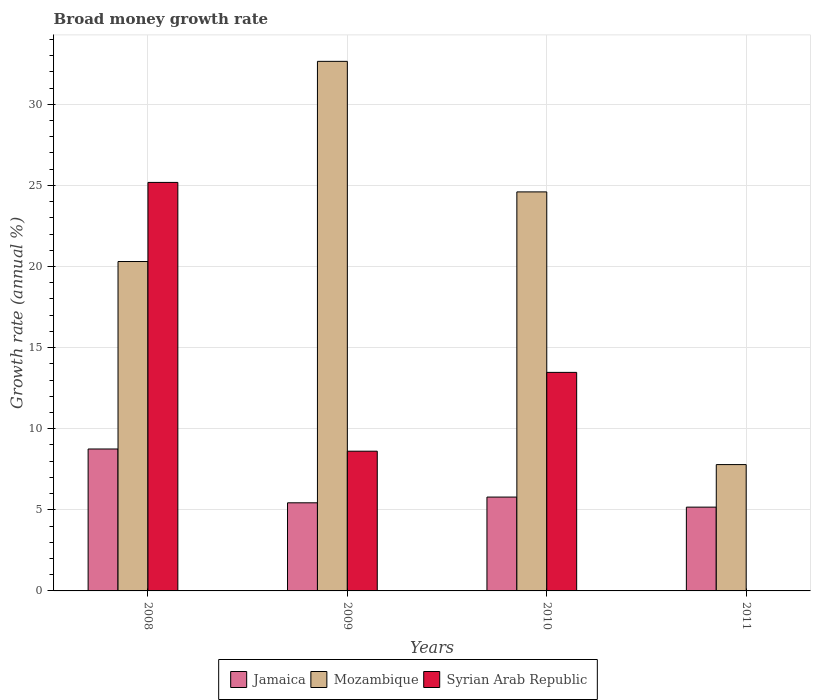How many different coloured bars are there?
Keep it short and to the point. 3. How many groups of bars are there?
Provide a short and direct response. 4. What is the label of the 4th group of bars from the left?
Give a very brief answer. 2011. What is the growth rate in Jamaica in 2010?
Make the answer very short. 5.79. Across all years, what is the maximum growth rate in Jamaica?
Give a very brief answer. 8.75. Across all years, what is the minimum growth rate in Mozambique?
Your answer should be compact. 7.79. What is the total growth rate in Jamaica in the graph?
Provide a short and direct response. 25.13. What is the difference between the growth rate in Jamaica in 2009 and that in 2011?
Provide a short and direct response. 0.27. What is the difference between the growth rate in Syrian Arab Republic in 2011 and the growth rate in Mozambique in 2009?
Give a very brief answer. -32.64. What is the average growth rate in Mozambique per year?
Offer a very short reply. 21.33. In the year 2010, what is the difference between the growth rate in Syrian Arab Republic and growth rate in Jamaica?
Ensure brevity in your answer.  7.69. What is the ratio of the growth rate in Mozambique in 2009 to that in 2011?
Keep it short and to the point. 4.19. Is the growth rate in Jamaica in 2008 less than that in 2011?
Give a very brief answer. No. Is the difference between the growth rate in Syrian Arab Republic in 2008 and 2009 greater than the difference between the growth rate in Jamaica in 2008 and 2009?
Provide a succinct answer. Yes. What is the difference between the highest and the second highest growth rate in Syrian Arab Republic?
Offer a terse response. 11.71. What is the difference between the highest and the lowest growth rate in Syrian Arab Republic?
Provide a short and direct response. 25.18. Is it the case that in every year, the sum of the growth rate in Syrian Arab Republic and growth rate in Mozambique is greater than the growth rate in Jamaica?
Your answer should be very brief. Yes. How many bars are there?
Offer a terse response. 11. How many years are there in the graph?
Make the answer very short. 4. What is the difference between two consecutive major ticks on the Y-axis?
Offer a very short reply. 5. How are the legend labels stacked?
Make the answer very short. Horizontal. What is the title of the graph?
Provide a succinct answer. Broad money growth rate. What is the label or title of the X-axis?
Your answer should be compact. Years. What is the label or title of the Y-axis?
Keep it short and to the point. Growth rate (annual %). What is the Growth rate (annual %) of Jamaica in 2008?
Make the answer very short. 8.75. What is the Growth rate (annual %) in Mozambique in 2008?
Your answer should be compact. 20.3. What is the Growth rate (annual %) in Syrian Arab Republic in 2008?
Ensure brevity in your answer.  25.18. What is the Growth rate (annual %) in Jamaica in 2009?
Keep it short and to the point. 5.43. What is the Growth rate (annual %) in Mozambique in 2009?
Provide a short and direct response. 32.64. What is the Growth rate (annual %) of Syrian Arab Republic in 2009?
Provide a succinct answer. 8.61. What is the Growth rate (annual %) in Jamaica in 2010?
Offer a very short reply. 5.79. What is the Growth rate (annual %) in Mozambique in 2010?
Offer a terse response. 24.6. What is the Growth rate (annual %) of Syrian Arab Republic in 2010?
Your answer should be very brief. 13.47. What is the Growth rate (annual %) in Jamaica in 2011?
Your response must be concise. 5.16. What is the Growth rate (annual %) of Mozambique in 2011?
Make the answer very short. 7.79. What is the Growth rate (annual %) in Syrian Arab Republic in 2011?
Offer a very short reply. 0. Across all years, what is the maximum Growth rate (annual %) in Jamaica?
Provide a succinct answer. 8.75. Across all years, what is the maximum Growth rate (annual %) of Mozambique?
Your answer should be very brief. 32.64. Across all years, what is the maximum Growth rate (annual %) of Syrian Arab Republic?
Your answer should be compact. 25.18. Across all years, what is the minimum Growth rate (annual %) of Jamaica?
Ensure brevity in your answer.  5.16. Across all years, what is the minimum Growth rate (annual %) in Mozambique?
Give a very brief answer. 7.79. What is the total Growth rate (annual %) of Jamaica in the graph?
Provide a short and direct response. 25.13. What is the total Growth rate (annual %) of Mozambique in the graph?
Offer a terse response. 85.33. What is the total Growth rate (annual %) of Syrian Arab Republic in the graph?
Provide a succinct answer. 47.27. What is the difference between the Growth rate (annual %) of Jamaica in 2008 and that in 2009?
Make the answer very short. 3.32. What is the difference between the Growth rate (annual %) of Mozambique in 2008 and that in 2009?
Provide a short and direct response. -12.34. What is the difference between the Growth rate (annual %) of Syrian Arab Republic in 2008 and that in 2009?
Provide a succinct answer. 16.57. What is the difference between the Growth rate (annual %) of Jamaica in 2008 and that in 2010?
Keep it short and to the point. 2.96. What is the difference between the Growth rate (annual %) in Mozambique in 2008 and that in 2010?
Offer a terse response. -4.29. What is the difference between the Growth rate (annual %) in Syrian Arab Republic in 2008 and that in 2010?
Offer a terse response. 11.71. What is the difference between the Growth rate (annual %) of Jamaica in 2008 and that in 2011?
Provide a succinct answer. 3.58. What is the difference between the Growth rate (annual %) in Mozambique in 2008 and that in 2011?
Offer a very short reply. 12.52. What is the difference between the Growth rate (annual %) of Jamaica in 2009 and that in 2010?
Offer a terse response. -0.35. What is the difference between the Growth rate (annual %) of Mozambique in 2009 and that in 2010?
Ensure brevity in your answer.  8.05. What is the difference between the Growth rate (annual %) of Syrian Arab Republic in 2009 and that in 2010?
Provide a short and direct response. -4.86. What is the difference between the Growth rate (annual %) of Jamaica in 2009 and that in 2011?
Make the answer very short. 0.27. What is the difference between the Growth rate (annual %) of Mozambique in 2009 and that in 2011?
Provide a succinct answer. 24.86. What is the difference between the Growth rate (annual %) of Jamaica in 2010 and that in 2011?
Your answer should be very brief. 0.62. What is the difference between the Growth rate (annual %) in Mozambique in 2010 and that in 2011?
Give a very brief answer. 16.81. What is the difference between the Growth rate (annual %) of Jamaica in 2008 and the Growth rate (annual %) of Mozambique in 2009?
Your answer should be compact. -23.89. What is the difference between the Growth rate (annual %) in Jamaica in 2008 and the Growth rate (annual %) in Syrian Arab Republic in 2009?
Your answer should be very brief. 0.14. What is the difference between the Growth rate (annual %) in Mozambique in 2008 and the Growth rate (annual %) in Syrian Arab Republic in 2009?
Your response must be concise. 11.69. What is the difference between the Growth rate (annual %) of Jamaica in 2008 and the Growth rate (annual %) of Mozambique in 2010?
Give a very brief answer. -15.85. What is the difference between the Growth rate (annual %) of Jamaica in 2008 and the Growth rate (annual %) of Syrian Arab Republic in 2010?
Your answer should be very brief. -4.72. What is the difference between the Growth rate (annual %) of Mozambique in 2008 and the Growth rate (annual %) of Syrian Arab Republic in 2010?
Provide a short and direct response. 6.83. What is the difference between the Growth rate (annual %) of Jamaica in 2008 and the Growth rate (annual %) of Mozambique in 2011?
Offer a very short reply. 0.96. What is the difference between the Growth rate (annual %) in Jamaica in 2009 and the Growth rate (annual %) in Mozambique in 2010?
Your response must be concise. -19.16. What is the difference between the Growth rate (annual %) of Jamaica in 2009 and the Growth rate (annual %) of Syrian Arab Republic in 2010?
Your answer should be compact. -8.04. What is the difference between the Growth rate (annual %) in Mozambique in 2009 and the Growth rate (annual %) in Syrian Arab Republic in 2010?
Give a very brief answer. 19.17. What is the difference between the Growth rate (annual %) of Jamaica in 2009 and the Growth rate (annual %) of Mozambique in 2011?
Give a very brief answer. -2.36. What is the difference between the Growth rate (annual %) of Jamaica in 2010 and the Growth rate (annual %) of Mozambique in 2011?
Your answer should be very brief. -2. What is the average Growth rate (annual %) of Jamaica per year?
Your answer should be compact. 6.28. What is the average Growth rate (annual %) of Mozambique per year?
Your answer should be very brief. 21.33. What is the average Growth rate (annual %) in Syrian Arab Republic per year?
Make the answer very short. 11.82. In the year 2008, what is the difference between the Growth rate (annual %) in Jamaica and Growth rate (annual %) in Mozambique?
Make the answer very short. -11.56. In the year 2008, what is the difference between the Growth rate (annual %) in Jamaica and Growth rate (annual %) in Syrian Arab Republic?
Ensure brevity in your answer.  -16.43. In the year 2008, what is the difference between the Growth rate (annual %) of Mozambique and Growth rate (annual %) of Syrian Arab Republic?
Keep it short and to the point. -4.88. In the year 2009, what is the difference between the Growth rate (annual %) in Jamaica and Growth rate (annual %) in Mozambique?
Make the answer very short. -27.21. In the year 2009, what is the difference between the Growth rate (annual %) in Jamaica and Growth rate (annual %) in Syrian Arab Republic?
Provide a short and direct response. -3.18. In the year 2009, what is the difference between the Growth rate (annual %) of Mozambique and Growth rate (annual %) of Syrian Arab Republic?
Ensure brevity in your answer.  24.03. In the year 2010, what is the difference between the Growth rate (annual %) of Jamaica and Growth rate (annual %) of Mozambique?
Offer a terse response. -18.81. In the year 2010, what is the difference between the Growth rate (annual %) of Jamaica and Growth rate (annual %) of Syrian Arab Republic?
Your answer should be compact. -7.69. In the year 2010, what is the difference between the Growth rate (annual %) in Mozambique and Growth rate (annual %) in Syrian Arab Republic?
Keep it short and to the point. 11.13. In the year 2011, what is the difference between the Growth rate (annual %) in Jamaica and Growth rate (annual %) in Mozambique?
Offer a very short reply. -2.62. What is the ratio of the Growth rate (annual %) in Jamaica in 2008 to that in 2009?
Ensure brevity in your answer.  1.61. What is the ratio of the Growth rate (annual %) of Mozambique in 2008 to that in 2009?
Provide a short and direct response. 0.62. What is the ratio of the Growth rate (annual %) of Syrian Arab Republic in 2008 to that in 2009?
Your answer should be very brief. 2.92. What is the ratio of the Growth rate (annual %) of Jamaica in 2008 to that in 2010?
Your answer should be very brief. 1.51. What is the ratio of the Growth rate (annual %) of Mozambique in 2008 to that in 2010?
Your response must be concise. 0.83. What is the ratio of the Growth rate (annual %) of Syrian Arab Republic in 2008 to that in 2010?
Give a very brief answer. 1.87. What is the ratio of the Growth rate (annual %) of Jamaica in 2008 to that in 2011?
Offer a terse response. 1.69. What is the ratio of the Growth rate (annual %) in Mozambique in 2008 to that in 2011?
Your response must be concise. 2.61. What is the ratio of the Growth rate (annual %) in Jamaica in 2009 to that in 2010?
Give a very brief answer. 0.94. What is the ratio of the Growth rate (annual %) of Mozambique in 2009 to that in 2010?
Ensure brevity in your answer.  1.33. What is the ratio of the Growth rate (annual %) in Syrian Arab Republic in 2009 to that in 2010?
Provide a short and direct response. 0.64. What is the ratio of the Growth rate (annual %) of Jamaica in 2009 to that in 2011?
Provide a succinct answer. 1.05. What is the ratio of the Growth rate (annual %) of Mozambique in 2009 to that in 2011?
Your response must be concise. 4.19. What is the ratio of the Growth rate (annual %) of Jamaica in 2010 to that in 2011?
Your answer should be very brief. 1.12. What is the ratio of the Growth rate (annual %) of Mozambique in 2010 to that in 2011?
Keep it short and to the point. 3.16. What is the difference between the highest and the second highest Growth rate (annual %) in Jamaica?
Your answer should be compact. 2.96. What is the difference between the highest and the second highest Growth rate (annual %) of Mozambique?
Your response must be concise. 8.05. What is the difference between the highest and the second highest Growth rate (annual %) of Syrian Arab Republic?
Your answer should be very brief. 11.71. What is the difference between the highest and the lowest Growth rate (annual %) in Jamaica?
Offer a very short reply. 3.58. What is the difference between the highest and the lowest Growth rate (annual %) of Mozambique?
Ensure brevity in your answer.  24.86. What is the difference between the highest and the lowest Growth rate (annual %) of Syrian Arab Republic?
Keep it short and to the point. 25.18. 